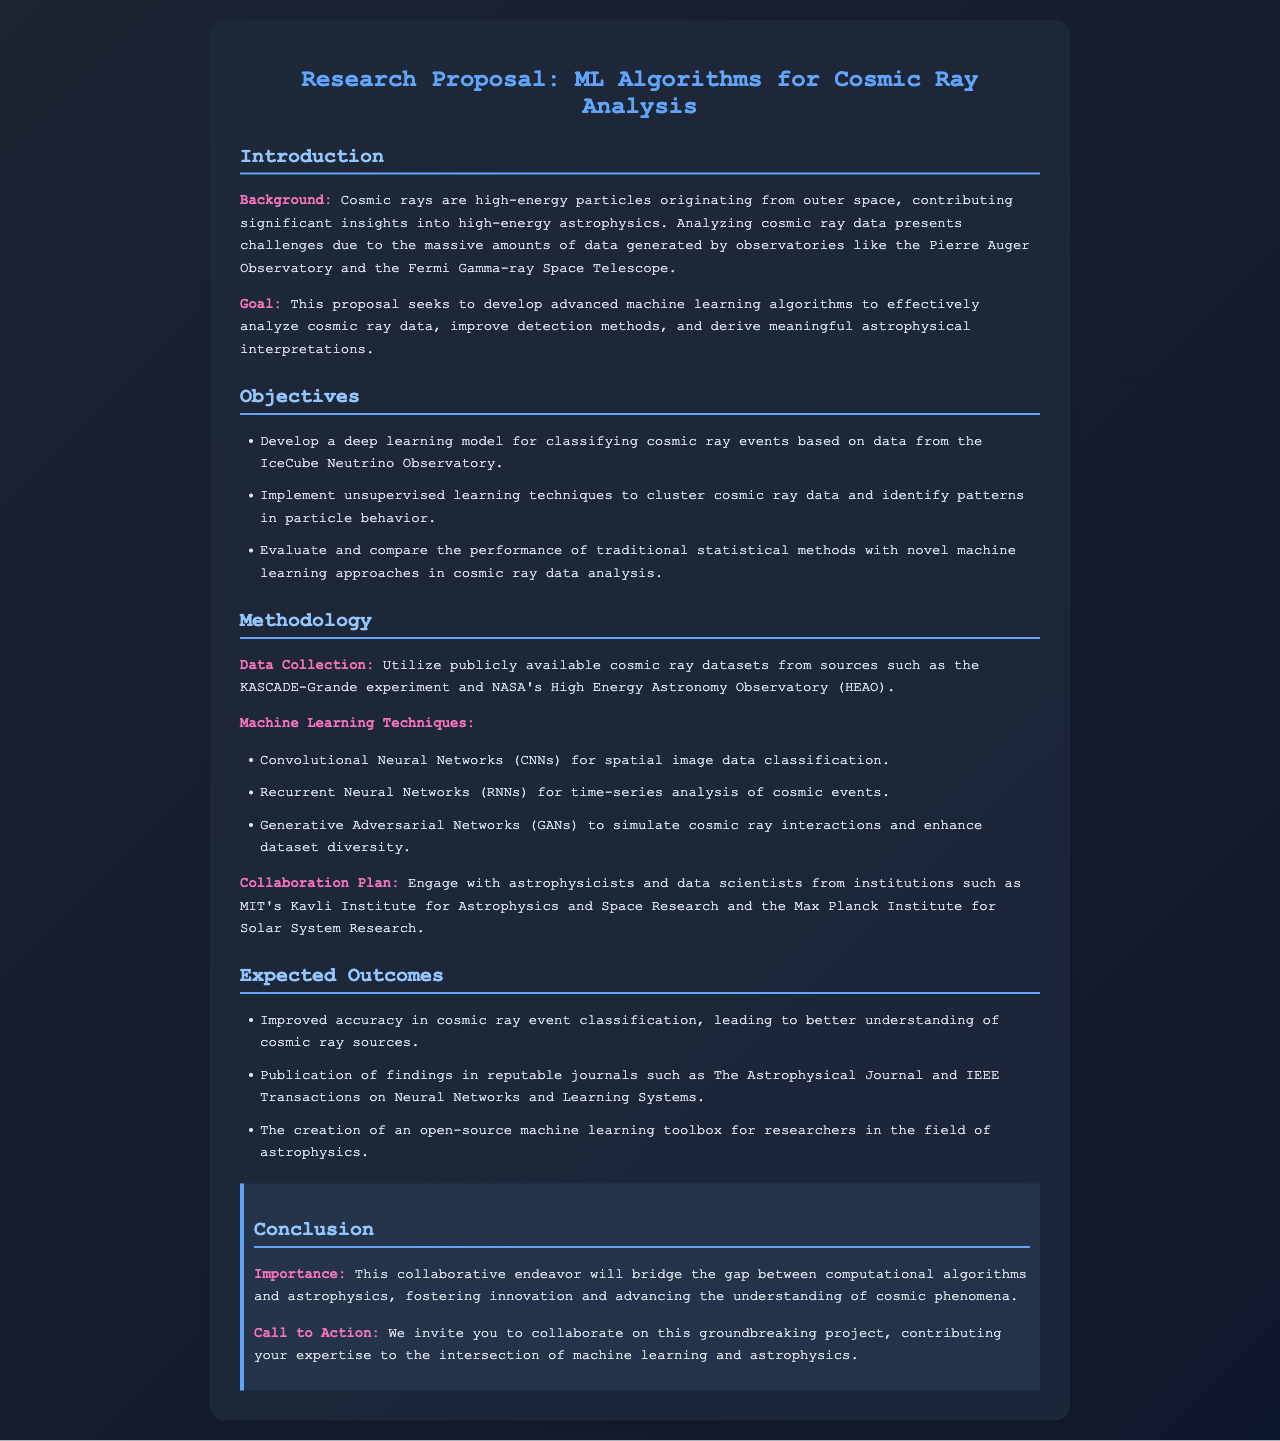What is the title of the proposal? The title of the proposal is stated in the heading of the document.
Answer: ML Algorithms for Cosmic Ray Analysis What are the three machine learning techniques mentioned in the methodology? The document lists specific machine learning techniques used in the analysis.
Answer: CNNs, RNNs, GANs Who are the collaborators from prestigious institutions mentioned? The methodology section specifies institutions involved in collaboration.
Answer: MIT and Max Planck Institute What is the goal of this research proposal? The goal is outlined in the introduction section of the document.
Answer: Develop advanced machine learning algorithms What is one expected outcome of the research? This outcome is mentioned in the expected outcomes section.
Answer: Improved accuracy in cosmic ray event classification What data sources will be utilized for this project? The data collection section specifies the sources of cosmic ray datasets.
Answer: KASCADE-Grande and NASA's HEAO What is the importance of this collaborative endeavor? The importance is highlighted in the conclusion.
Answer: Bridge the gap between computational algorithms and astrophysics How many objectives are outlined in the proposal? The objectives section lists specific goals of the research.
Answer: Three 